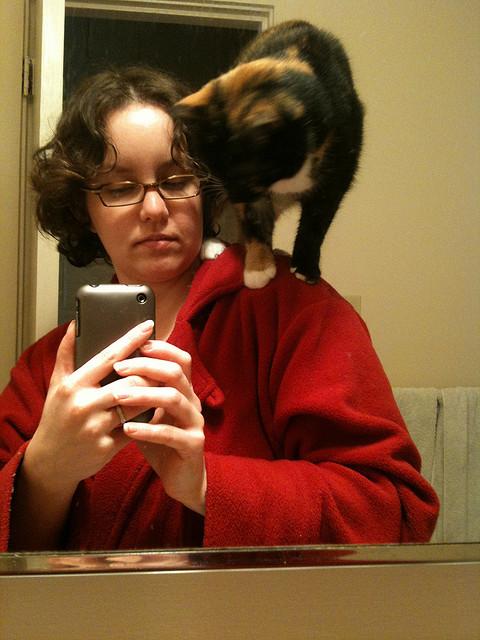What color is the woman's shirt?
Give a very brief answer. Red. Who is joining the woman in her 'selfie'?
Answer briefly. Cat. What is the lady holding?
Keep it brief. Phone. 